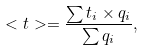Convert formula to latex. <formula><loc_0><loc_0><loc_500><loc_500>< t > = \frac { \sum t _ { i } \times q _ { i } } { \sum q _ { i } } ,</formula> 